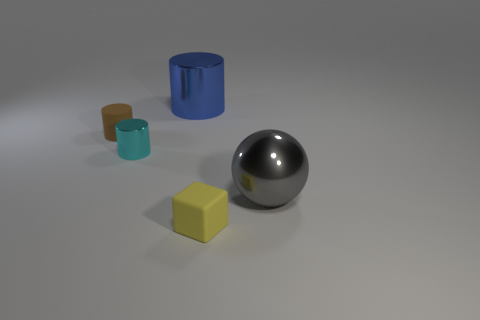How would the appearance of the metal sphere change if the lighting in the scene were dimmer? If the lighting in the scene were dimmer, the metal sphere would reflect less light, resulting in a darker appearance with more subdued and less defined highlights. The reflections on its surface would also be less intense, and the contrast within the reflections would decrease, making the sphere look less shiny. 